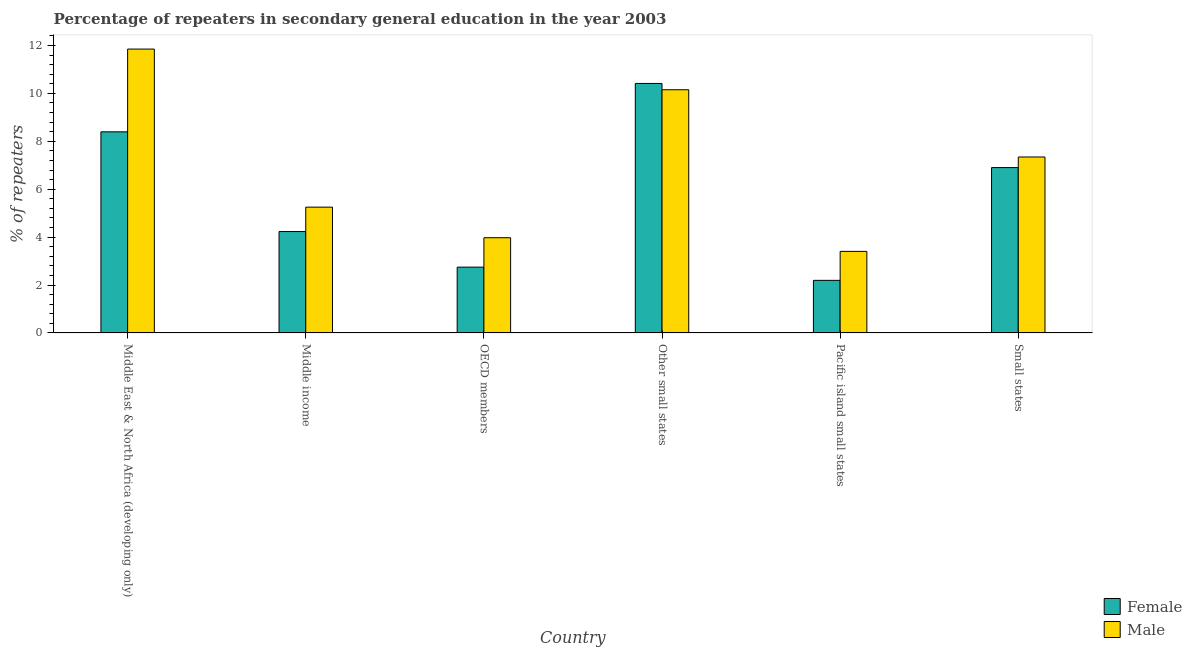How many different coloured bars are there?
Keep it short and to the point. 2. How many groups of bars are there?
Give a very brief answer. 6. Are the number of bars per tick equal to the number of legend labels?
Provide a short and direct response. Yes. How many bars are there on the 2nd tick from the left?
Give a very brief answer. 2. How many bars are there on the 6th tick from the right?
Make the answer very short. 2. What is the label of the 5th group of bars from the left?
Give a very brief answer. Pacific island small states. What is the percentage of female repeaters in Middle East & North Africa (developing only)?
Keep it short and to the point. 8.4. Across all countries, what is the maximum percentage of male repeaters?
Your response must be concise. 11.85. Across all countries, what is the minimum percentage of male repeaters?
Give a very brief answer. 3.41. In which country was the percentage of female repeaters maximum?
Offer a terse response. Other small states. In which country was the percentage of male repeaters minimum?
Provide a short and direct response. Pacific island small states. What is the total percentage of female repeaters in the graph?
Your answer should be compact. 34.89. What is the difference between the percentage of male repeaters in Middle income and that in Small states?
Provide a short and direct response. -2.09. What is the difference between the percentage of female repeaters in Middle income and the percentage of male repeaters in Middle East & North Africa (developing only)?
Your answer should be compact. -7.62. What is the average percentage of female repeaters per country?
Ensure brevity in your answer.  5.81. What is the difference between the percentage of male repeaters and percentage of female repeaters in Pacific island small states?
Offer a very short reply. 1.21. In how many countries, is the percentage of female repeaters greater than 1.6 %?
Your answer should be compact. 6. What is the ratio of the percentage of female repeaters in Middle East & North Africa (developing only) to that in Other small states?
Give a very brief answer. 0.81. Is the difference between the percentage of female repeaters in Other small states and Pacific island small states greater than the difference between the percentage of male repeaters in Other small states and Pacific island small states?
Keep it short and to the point. Yes. What is the difference between the highest and the second highest percentage of female repeaters?
Provide a short and direct response. 2.02. What is the difference between the highest and the lowest percentage of male repeaters?
Offer a terse response. 8.45. How many bars are there?
Give a very brief answer. 12. What is the difference between two consecutive major ticks on the Y-axis?
Your answer should be compact. 2. Does the graph contain any zero values?
Your answer should be compact. No. Does the graph contain grids?
Ensure brevity in your answer.  No. How are the legend labels stacked?
Your answer should be compact. Vertical. What is the title of the graph?
Your answer should be very brief. Percentage of repeaters in secondary general education in the year 2003. Does "Fraud firms" appear as one of the legend labels in the graph?
Give a very brief answer. No. What is the label or title of the Y-axis?
Provide a succinct answer. % of repeaters. What is the % of repeaters in Female in Middle East & North Africa (developing only)?
Your response must be concise. 8.4. What is the % of repeaters of Male in Middle East & North Africa (developing only)?
Offer a very short reply. 11.85. What is the % of repeaters in Female in Middle income?
Make the answer very short. 4.23. What is the % of repeaters in Male in Middle income?
Keep it short and to the point. 5.25. What is the % of repeaters of Female in OECD members?
Offer a terse response. 2.75. What is the % of repeaters of Male in OECD members?
Your answer should be compact. 3.97. What is the % of repeaters of Female in Other small states?
Provide a succinct answer. 10.42. What is the % of repeaters in Male in Other small states?
Provide a short and direct response. 10.15. What is the % of repeaters in Female in Pacific island small states?
Ensure brevity in your answer.  2.2. What is the % of repeaters of Male in Pacific island small states?
Provide a succinct answer. 3.41. What is the % of repeaters in Female in Small states?
Your answer should be very brief. 6.9. What is the % of repeaters in Male in Small states?
Your response must be concise. 7.35. Across all countries, what is the maximum % of repeaters in Female?
Provide a succinct answer. 10.42. Across all countries, what is the maximum % of repeaters in Male?
Offer a very short reply. 11.85. Across all countries, what is the minimum % of repeaters of Female?
Your response must be concise. 2.2. Across all countries, what is the minimum % of repeaters of Male?
Provide a short and direct response. 3.41. What is the total % of repeaters of Female in the graph?
Offer a terse response. 34.89. What is the total % of repeaters in Male in the graph?
Your answer should be very brief. 41.98. What is the difference between the % of repeaters of Female in Middle East & North Africa (developing only) and that in Middle income?
Provide a succinct answer. 4.16. What is the difference between the % of repeaters in Male in Middle East & North Africa (developing only) and that in Middle income?
Provide a succinct answer. 6.6. What is the difference between the % of repeaters in Female in Middle East & North Africa (developing only) and that in OECD members?
Keep it short and to the point. 5.65. What is the difference between the % of repeaters in Male in Middle East & North Africa (developing only) and that in OECD members?
Provide a succinct answer. 7.88. What is the difference between the % of repeaters in Female in Middle East & North Africa (developing only) and that in Other small states?
Make the answer very short. -2.02. What is the difference between the % of repeaters of Male in Middle East & North Africa (developing only) and that in Other small states?
Offer a very short reply. 1.7. What is the difference between the % of repeaters in Female in Middle East & North Africa (developing only) and that in Pacific island small states?
Your answer should be very brief. 6.2. What is the difference between the % of repeaters in Male in Middle East & North Africa (developing only) and that in Pacific island small states?
Offer a terse response. 8.45. What is the difference between the % of repeaters of Female in Middle East & North Africa (developing only) and that in Small states?
Offer a terse response. 1.49. What is the difference between the % of repeaters in Male in Middle East & North Africa (developing only) and that in Small states?
Offer a very short reply. 4.51. What is the difference between the % of repeaters of Female in Middle income and that in OECD members?
Your answer should be compact. 1.49. What is the difference between the % of repeaters in Male in Middle income and that in OECD members?
Provide a succinct answer. 1.28. What is the difference between the % of repeaters of Female in Middle income and that in Other small states?
Your answer should be compact. -6.18. What is the difference between the % of repeaters in Male in Middle income and that in Other small states?
Make the answer very short. -4.9. What is the difference between the % of repeaters in Female in Middle income and that in Pacific island small states?
Ensure brevity in your answer.  2.04. What is the difference between the % of repeaters in Male in Middle income and that in Pacific island small states?
Keep it short and to the point. 1.85. What is the difference between the % of repeaters of Female in Middle income and that in Small states?
Offer a very short reply. -2.67. What is the difference between the % of repeaters in Male in Middle income and that in Small states?
Offer a very short reply. -2.09. What is the difference between the % of repeaters of Female in OECD members and that in Other small states?
Make the answer very short. -7.67. What is the difference between the % of repeaters in Male in OECD members and that in Other small states?
Provide a succinct answer. -6.18. What is the difference between the % of repeaters of Female in OECD members and that in Pacific island small states?
Provide a short and direct response. 0.55. What is the difference between the % of repeaters in Male in OECD members and that in Pacific island small states?
Make the answer very short. 0.57. What is the difference between the % of repeaters of Female in OECD members and that in Small states?
Ensure brevity in your answer.  -4.16. What is the difference between the % of repeaters of Male in OECD members and that in Small states?
Your answer should be very brief. -3.37. What is the difference between the % of repeaters of Female in Other small states and that in Pacific island small states?
Make the answer very short. 8.22. What is the difference between the % of repeaters of Male in Other small states and that in Pacific island small states?
Make the answer very short. 6.75. What is the difference between the % of repeaters of Female in Other small states and that in Small states?
Provide a short and direct response. 3.51. What is the difference between the % of repeaters in Male in Other small states and that in Small states?
Provide a succinct answer. 2.81. What is the difference between the % of repeaters in Female in Pacific island small states and that in Small states?
Provide a succinct answer. -4.71. What is the difference between the % of repeaters of Male in Pacific island small states and that in Small states?
Make the answer very short. -3.94. What is the difference between the % of repeaters of Female in Middle East & North Africa (developing only) and the % of repeaters of Male in Middle income?
Make the answer very short. 3.14. What is the difference between the % of repeaters of Female in Middle East & North Africa (developing only) and the % of repeaters of Male in OECD members?
Your response must be concise. 4.42. What is the difference between the % of repeaters of Female in Middle East & North Africa (developing only) and the % of repeaters of Male in Other small states?
Make the answer very short. -1.76. What is the difference between the % of repeaters in Female in Middle East & North Africa (developing only) and the % of repeaters in Male in Pacific island small states?
Give a very brief answer. 4.99. What is the difference between the % of repeaters in Female in Middle East & North Africa (developing only) and the % of repeaters in Male in Small states?
Offer a very short reply. 1.05. What is the difference between the % of repeaters of Female in Middle income and the % of repeaters of Male in OECD members?
Provide a short and direct response. 0.26. What is the difference between the % of repeaters in Female in Middle income and the % of repeaters in Male in Other small states?
Give a very brief answer. -5.92. What is the difference between the % of repeaters in Female in Middle income and the % of repeaters in Male in Pacific island small states?
Make the answer very short. 0.83. What is the difference between the % of repeaters of Female in Middle income and the % of repeaters of Male in Small states?
Provide a succinct answer. -3.11. What is the difference between the % of repeaters in Female in OECD members and the % of repeaters in Male in Other small states?
Make the answer very short. -7.41. What is the difference between the % of repeaters of Female in OECD members and the % of repeaters of Male in Pacific island small states?
Make the answer very short. -0.66. What is the difference between the % of repeaters of Female in OECD members and the % of repeaters of Male in Small states?
Your answer should be very brief. -4.6. What is the difference between the % of repeaters in Female in Other small states and the % of repeaters in Male in Pacific island small states?
Your response must be concise. 7.01. What is the difference between the % of repeaters in Female in Other small states and the % of repeaters in Male in Small states?
Ensure brevity in your answer.  3.07. What is the difference between the % of repeaters in Female in Pacific island small states and the % of repeaters in Male in Small states?
Make the answer very short. -5.15. What is the average % of repeaters in Female per country?
Provide a short and direct response. 5.81. What is the average % of repeaters in Male per country?
Your answer should be compact. 7. What is the difference between the % of repeaters of Female and % of repeaters of Male in Middle East & North Africa (developing only)?
Keep it short and to the point. -3.46. What is the difference between the % of repeaters in Female and % of repeaters in Male in Middle income?
Make the answer very short. -1.02. What is the difference between the % of repeaters in Female and % of repeaters in Male in OECD members?
Keep it short and to the point. -1.23. What is the difference between the % of repeaters in Female and % of repeaters in Male in Other small states?
Keep it short and to the point. 0.26. What is the difference between the % of repeaters in Female and % of repeaters in Male in Pacific island small states?
Your answer should be compact. -1.21. What is the difference between the % of repeaters of Female and % of repeaters of Male in Small states?
Your answer should be compact. -0.44. What is the ratio of the % of repeaters of Female in Middle East & North Africa (developing only) to that in Middle income?
Your answer should be very brief. 1.98. What is the ratio of the % of repeaters in Male in Middle East & North Africa (developing only) to that in Middle income?
Your answer should be very brief. 2.26. What is the ratio of the % of repeaters of Female in Middle East & North Africa (developing only) to that in OECD members?
Offer a terse response. 3.06. What is the ratio of the % of repeaters of Male in Middle East & North Africa (developing only) to that in OECD members?
Provide a short and direct response. 2.98. What is the ratio of the % of repeaters of Female in Middle East & North Africa (developing only) to that in Other small states?
Provide a succinct answer. 0.81. What is the ratio of the % of repeaters in Male in Middle East & North Africa (developing only) to that in Other small states?
Offer a terse response. 1.17. What is the ratio of the % of repeaters of Female in Middle East & North Africa (developing only) to that in Pacific island small states?
Provide a succinct answer. 3.82. What is the ratio of the % of repeaters in Male in Middle East & North Africa (developing only) to that in Pacific island small states?
Give a very brief answer. 3.48. What is the ratio of the % of repeaters of Female in Middle East & North Africa (developing only) to that in Small states?
Provide a succinct answer. 1.22. What is the ratio of the % of repeaters of Male in Middle East & North Africa (developing only) to that in Small states?
Offer a very short reply. 1.61. What is the ratio of the % of repeaters in Female in Middle income to that in OECD members?
Your answer should be very brief. 1.54. What is the ratio of the % of repeaters in Male in Middle income to that in OECD members?
Make the answer very short. 1.32. What is the ratio of the % of repeaters in Female in Middle income to that in Other small states?
Provide a short and direct response. 0.41. What is the ratio of the % of repeaters in Male in Middle income to that in Other small states?
Offer a terse response. 0.52. What is the ratio of the % of repeaters of Female in Middle income to that in Pacific island small states?
Keep it short and to the point. 1.93. What is the ratio of the % of repeaters of Male in Middle income to that in Pacific island small states?
Your answer should be compact. 1.54. What is the ratio of the % of repeaters in Female in Middle income to that in Small states?
Offer a very short reply. 0.61. What is the ratio of the % of repeaters in Male in Middle income to that in Small states?
Your response must be concise. 0.71. What is the ratio of the % of repeaters in Female in OECD members to that in Other small states?
Ensure brevity in your answer.  0.26. What is the ratio of the % of repeaters in Male in OECD members to that in Other small states?
Provide a succinct answer. 0.39. What is the ratio of the % of repeaters of Female in OECD members to that in Pacific island small states?
Ensure brevity in your answer.  1.25. What is the ratio of the % of repeaters in Male in OECD members to that in Pacific island small states?
Give a very brief answer. 1.17. What is the ratio of the % of repeaters of Female in OECD members to that in Small states?
Give a very brief answer. 0.4. What is the ratio of the % of repeaters of Male in OECD members to that in Small states?
Keep it short and to the point. 0.54. What is the ratio of the % of repeaters of Female in Other small states to that in Pacific island small states?
Keep it short and to the point. 4.74. What is the ratio of the % of repeaters in Male in Other small states to that in Pacific island small states?
Ensure brevity in your answer.  2.98. What is the ratio of the % of repeaters in Female in Other small states to that in Small states?
Keep it short and to the point. 1.51. What is the ratio of the % of repeaters of Male in Other small states to that in Small states?
Your response must be concise. 1.38. What is the ratio of the % of repeaters in Female in Pacific island small states to that in Small states?
Your answer should be very brief. 0.32. What is the ratio of the % of repeaters of Male in Pacific island small states to that in Small states?
Your response must be concise. 0.46. What is the difference between the highest and the second highest % of repeaters in Female?
Give a very brief answer. 2.02. What is the difference between the highest and the second highest % of repeaters of Male?
Provide a short and direct response. 1.7. What is the difference between the highest and the lowest % of repeaters of Female?
Your answer should be very brief. 8.22. What is the difference between the highest and the lowest % of repeaters of Male?
Your answer should be very brief. 8.45. 